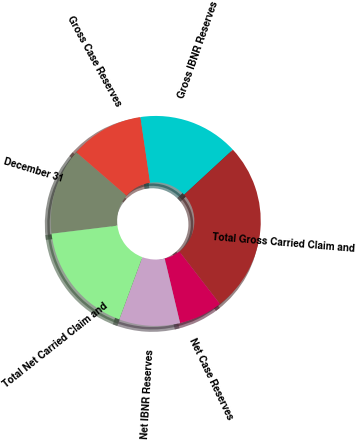<chart> <loc_0><loc_0><loc_500><loc_500><pie_chart><fcel>December 31<fcel>Gross Case Reserves<fcel>Gross IBNR Reserves<fcel>Total Gross Carried Claim and<fcel>Net Case Reserves<fcel>Net IBNR Reserves<fcel>Total Net Carried Claim and<nl><fcel>13.29%<fcel>11.32%<fcel>15.46%<fcel>26.39%<fcel>6.75%<fcel>9.36%<fcel>17.42%<nl></chart> 